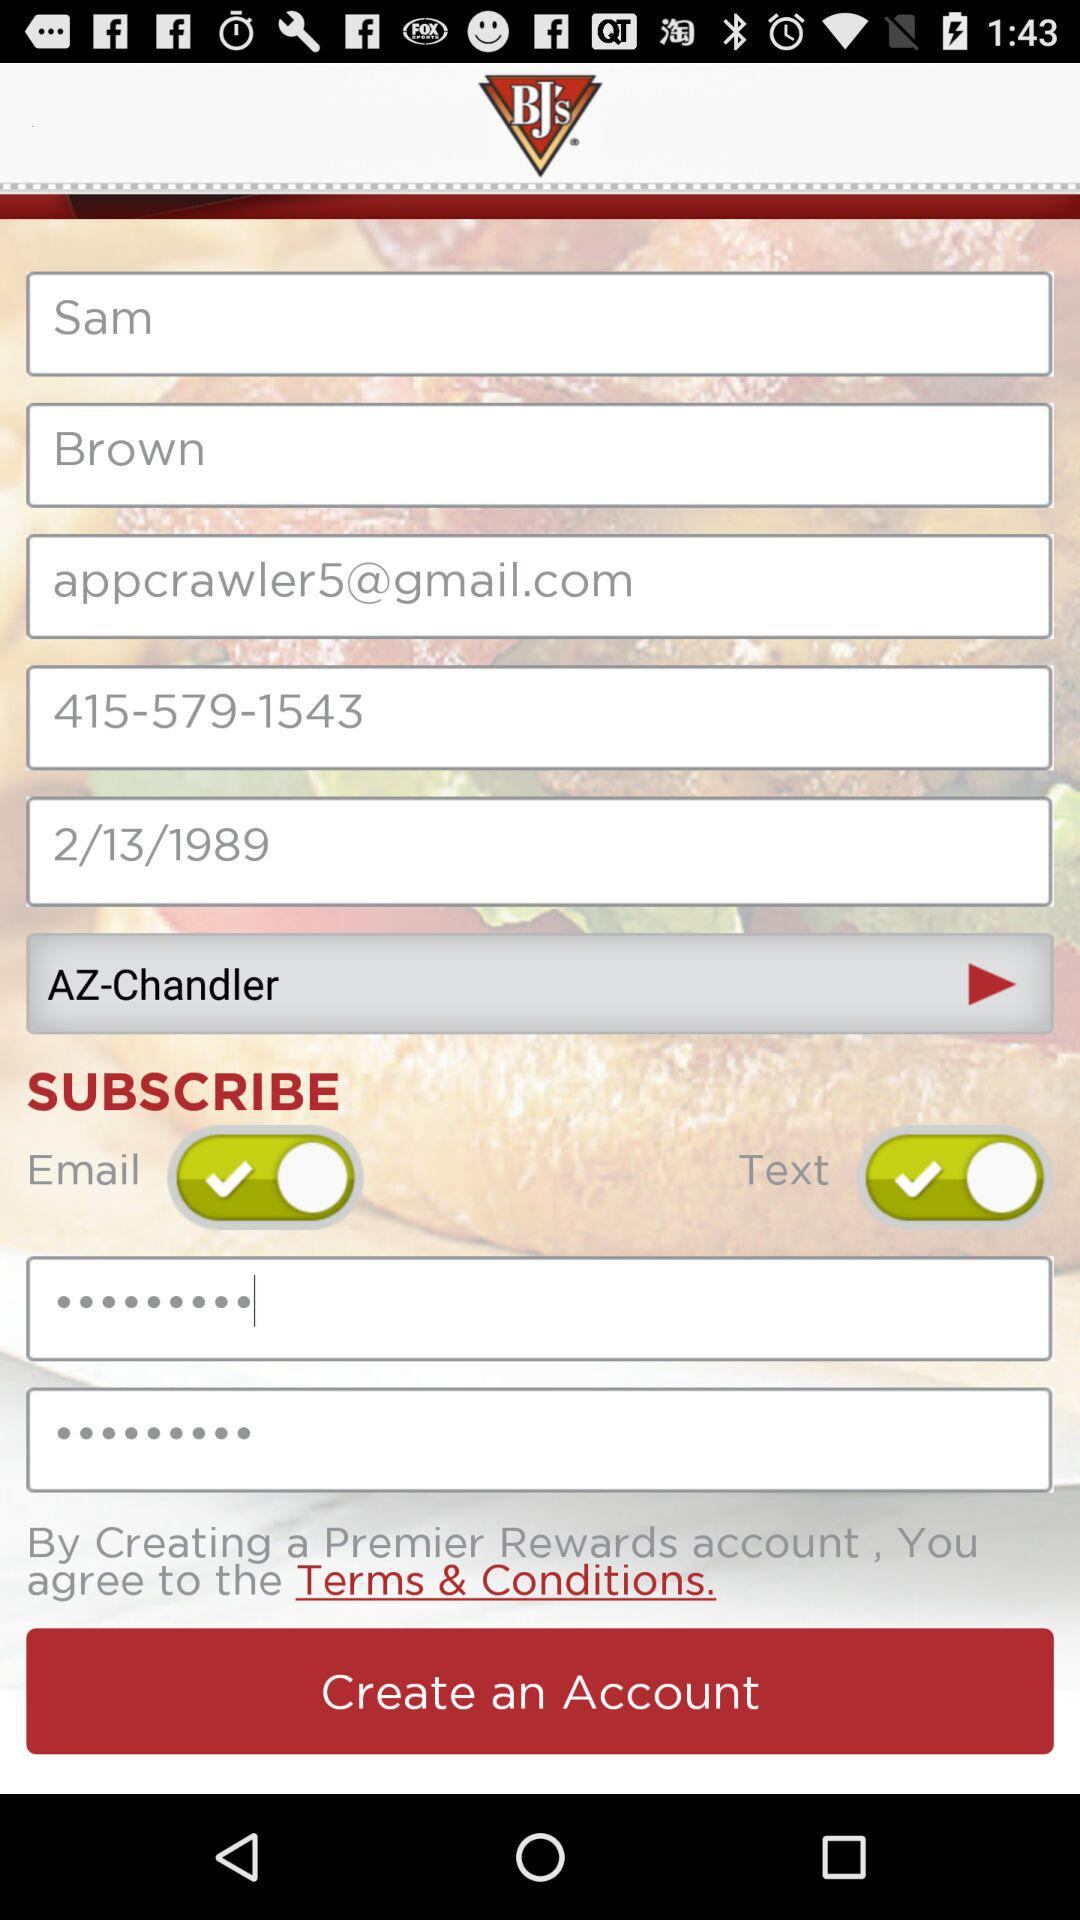What is the email address? The email address is appcrawler5@gmail.com. 